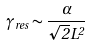<formula> <loc_0><loc_0><loc_500><loc_500>\gamma _ { r e s } \sim \frac { \alpha } { \sqrt { 2 } L ^ { 2 } }</formula> 